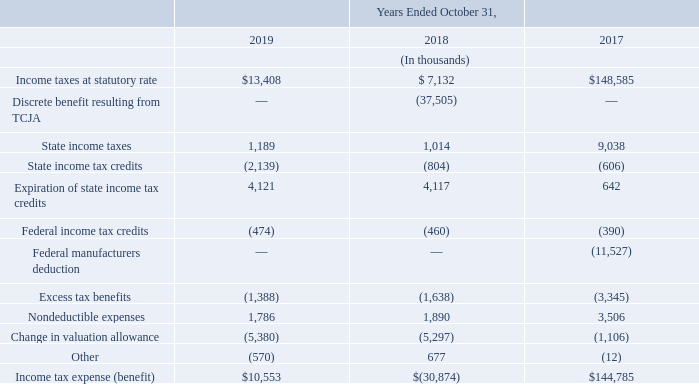At the end of each reporting period, the Company evaluates all available information at that time to determine if it is more likely than not that some or all of these credits will be utilized. As of October 31, 2019, 2018, and 2017, the Company determined that a total of $1.8 million, $0.7 million, and $0.6 million, respectively, would be recovered. Accordingly, those amounts were released from the valuation allowance and benefited deferred tax expense in the respective periods.
The differences between the consolidated effective income tax rate and the federal statutory rate effective during the applicable year presented are as follows:
What is the Income taxes at statutory rate for fiscal years 2019 and 2018 respectively?
Answer scale should be: thousand. $13,408, $ 7,132. What is the State income taxes for fiscal years 2019 and 2018 respectively?
Answer scale should be: thousand. 1,189, 1,014. How much credits would be recovered for 2019, 2018 and 2017 respectively? $1.8 million, $0.7 million, and $0.6 million. What is the average Income taxes at statutory rate for fiscal years 2019 and 2018?
Answer scale should be: thousand. (13,408+ 7,132)/2
Answer: 10270. What is the average state income taxes for fiscal years 2019 and 2018?
Answer scale should be: thousand. (1,189+1,014)/2
Answer: 1101.5. What is the change in Income taxes at statutory rate between fiscal years 2019 and 2018?
Answer scale should be: thousand. 13,408-7,132
Answer: 6276. 